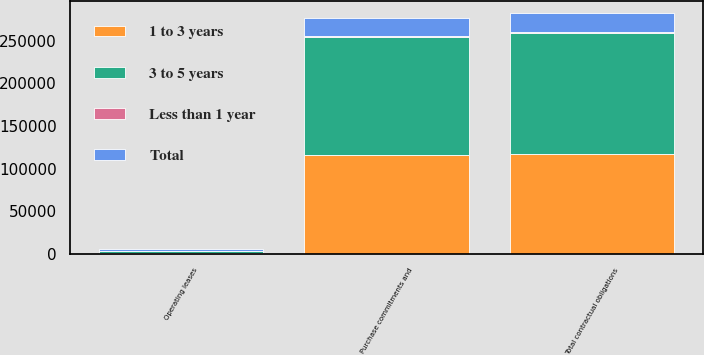<chart> <loc_0><loc_0><loc_500><loc_500><stacked_bar_chart><ecel><fcel>Operating leases<fcel>Purchase commitments and<fcel>Total contractual obligations<nl><fcel>3 to 5 years<fcel>2956<fcel>137936<fcel>140892<nl><fcel>1 to 3 years<fcel>1298<fcel>116295<fcel>117593<nl><fcel>Total<fcel>1622<fcel>20391<fcel>22013<nl><fcel>Less than 1 year<fcel>36<fcel>1250<fcel>1286<nl></chart> 